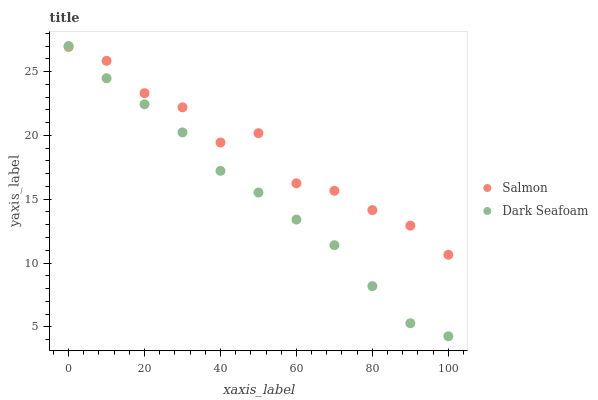Does Dark Seafoam have the minimum area under the curve?
Answer yes or no. Yes. Does Salmon have the maximum area under the curve?
Answer yes or no. Yes. Does Salmon have the minimum area under the curve?
Answer yes or no. No. Is Dark Seafoam the smoothest?
Answer yes or no. Yes. Is Salmon the roughest?
Answer yes or no. Yes. Is Salmon the smoothest?
Answer yes or no. No. Does Dark Seafoam have the lowest value?
Answer yes or no. Yes. Does Salmon have the lowest value?
Answer yes or no. No. Does Dark Seafoam have the highest value?
Answer yes or no. Yes. Does Salmon have the highest value?
Answer yes or no. No. Does Salmon intersect Dark Seafoam?
Answer yes or no. Yes. Is Salmon less than Dark Seafoam?
Answer yes or no. No. Is Salmon greater than Dark Seafoam?
Answer yes or no. No. 